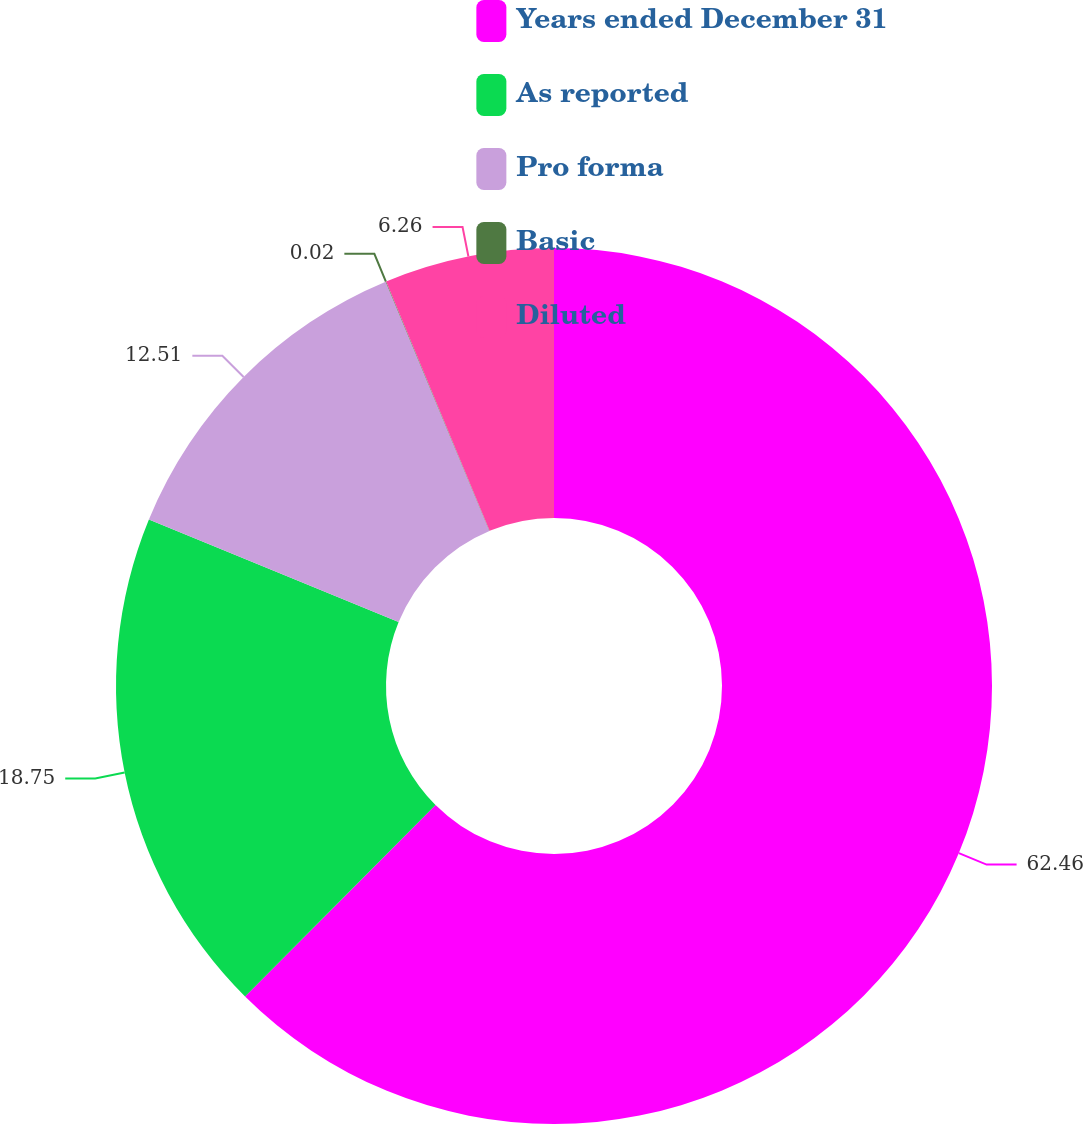<chart> <loc_0><loc_0><loc_500><loc_500><pie_chart><fcel>Years ended December 31<fcel>As reported<fcel>Pro forma<fcel>Basic<fcel>Diluted<nl><fcel>62.46%<fcel>18.75%<fcel>12.51%<fcel>0.02%<fcel>6.26%<nl></chart> 